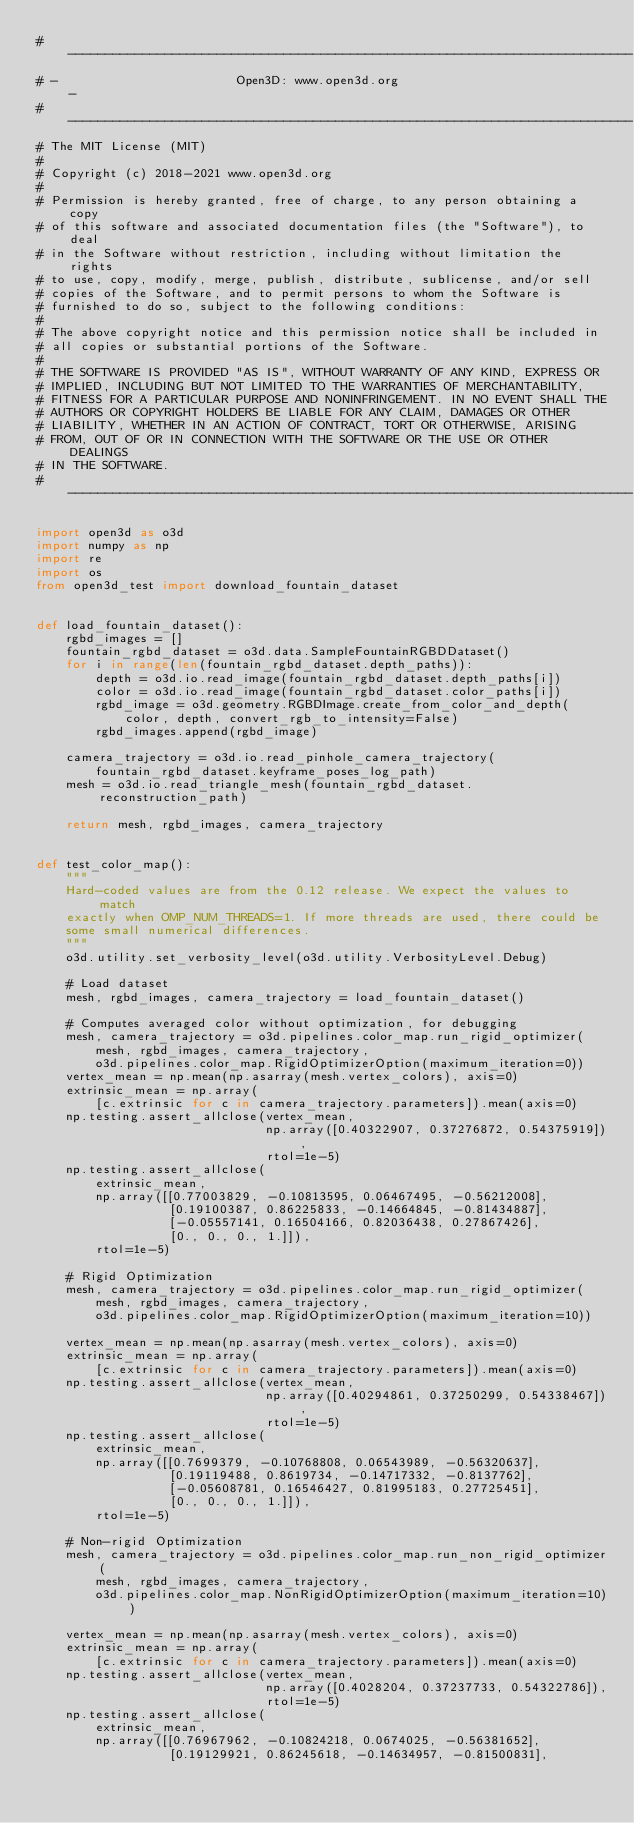Convert code to text. <code><loc_0><loc_0><loc_500><loc_500><_Python_># ----------------------------------------------------------------------------
# -                        Open3D: www.open3d.org                            -
# ----------------------------------------------------------------------------
# The MIT License (MIT)
#
# Copyright (c) 2018-2021 www.open3d.org
#
# Permission is hereby granted, free of charge, to any person obtaining a copy
# of this software and associated documentation files (the "Software"), to deal
# in the Software without restriction, including without limitation the rights
# to use, copy, modify, merge, publish, distribute, sublicense, and/or sell
# copies of the Software, and to permit persons to whom the Software is
# furnished to do so, subject to the following conditions:
#
# The above copyright notice and this permission notice shall be included in
# all copies or substantial portions of the Software.
#
# THE SOFTWARE IS PROVIDED "AS IS", WITHOUT WARRANTY OF ANY KIND, EXPRESS OR
# IMPLIED, INCLUDING BUT NOT LIMITED TO THE WARRANTIES OF MERCHANTABILITY,
# FITNESS FOR A PARTICULAR PURPOSE AND NONINFRINGEMENT. IN NO EVENT SHALL THE
# AUTHORS OR COPYRIGHT HOLDERS BE LIABLE FOR ANY CLAIM, DAMAGES OR OTHER
# LIABILITY, WHETHER IN AN ACTION OF CONTRACT, TORT OR OTHERWISE, ARISING
# FROM, OUT OF OR IN CONNECTION WITH THE SOFTWARE OR THE USE OR OTHER DEALINGS
# IN THE SOFTWARE.
# ----------------------------------------------------------------------------

import open3d as o3d
import numpy as np
import re
import os
from open3d_test import download_fountain_dataset


def load_fountain_dataset():
    rgbd_images = []
    fountain_rgbd_dataset = o3d.data.SampleFountainRGBDDataset()
    for i in range(len(fountain_rgbd_dataset.depth_paths)):
        depth = o3d.io.read_image(fountain_rgbd_dataset.depth_paths[i])
        color = o3d.io.read_image(fountain_rgbd_dataset.color_paths[i])
        rgbd_image = o3d.geometry.RGBDImage.create_from_color_and_depth(
            color, depth, convert_rgb_to_intensity=False)
        rgbd_images.append(rgbd_image)

    camera_trajectory = o3d.io.read_pinhole_camera_trajectory(
        fountain_rgbd_dataset.keyframe_poses_log_path)
    mesh = o3d.io.read_triangle_mesh(fountain_rgbd_dataset.reconstruction_path)

    return mesh, rgbd_images, camera_trajectory


def test_color_map():
    """
    Hard-coded values are from the 0.12 release. We expect the values to match
    exactly when OMP_NUM_THREADS=1. If more threads are used, there could be
    some small numerical differences.
    """
    o3d.utility.set_verbosity_level(o3d.utility.VerbosityLevel.Debug)

    # Load dataset
    mesh, rgbd_images, camera_trajectory = load_fountain_dataset()

    # Computes averaged color without optimization, for debugging
    mesh, camera_trajectory = o3d.pipelines.color_map.run_rigid_optimizer(
        mesh, rgbd_images, camera_trajectory,
        o3d.pipelines.color_map.RigidOptimizerOption(maximum_iteration=0))
    vertex_mean = np.mean(np.asarray(mesh.vertex_colors), axis=0)
    extrinsic_mean = np.array(
        [c.extrinsic for c in camera_trajectory.parameters]).mean(axis=0)
    np.testing.assert_allclose(vertex_mean,
                               np.array([0.40322907, 0.37276872, 0.54375919]),
                               rtol=1e-5)
    np.testing.assert_allclose(
        extrinsic_mean,
        np.array([[0.77003829, -0.10813595, 0.06467495, -0.56212008],
                  [0.19100387, 0.86225833, -0.14664845, -0.81434887],
                  [-0.05557141, 0.16504166, 0.82036438, 0.27867426],
                  [0., 0., 0., 1.]]),
        rtol=1e-5)

    # Rigid Optimization
    mesh, camera_trajectory = o3d.pipelines.color_map.run_rigid_optimizer(
        mesh, rgbd_images, camera_trajectory,
        o3d.pipelines.color_map.RigidOptimizerOption(maximum_iteration=10))

    vertex_mean = np.mean(np.asarray(mesh.vertex_colors), axis=0)
    extrinsic_mean = np.array(
        [c.extrinsic for c in camera_trajectory.parameters]).mean(axis=0)
    np.testing.assert_allclose(vertex_mean,
                               np.array([0.40294861, 0.37250299, 0.54338467]),
                               rtol=1e-5)
    np.testing.assert_allclose(
        extrinsic_mean,
        np.array([[0.7699379, -0.10768808, 0.06543989, -0.56320637],
                  [0.19119488, 0.8619734, -0.14717332, -0.8137762],
                  [-0.05608781, 0.16546427, 0.81995183, 0.27725451],
                  [0., 0., 0., 1.]]),
        rtol=1e-5)

    # Non-rigid Optimization
    mesh, camera_trajectory = o3d.pipelines.color_map.run_non_rigid_optimizer(
        mesh, rgbd_images, camera_trajectory,
        o3d.pipelines.color_map.NonRigidOptimizerOption(maximum_iteration=10))

    vertex_mean = np.mean(np.asarray(mesh.vertex_colors), axis=0)
    extrinsic_mean = np.array(
        [c.extrinsic for c in camera_trajectory.parameters]).mean(axis=0)
    np.testing.assert_allclose(vertex_mean,
                               np.array([0.4028204, 0.37237733, 0.54322786]),
                               rtol=1e-5)
    np.testing.assert_allclose(
        extrinsic_mean,
        np.array([[0.76967962, -0.10824218, 0.0674025, -0.56381652],
                  [0.19129921, 0.86245618, -0.14634957, -0.81500831],</code> 